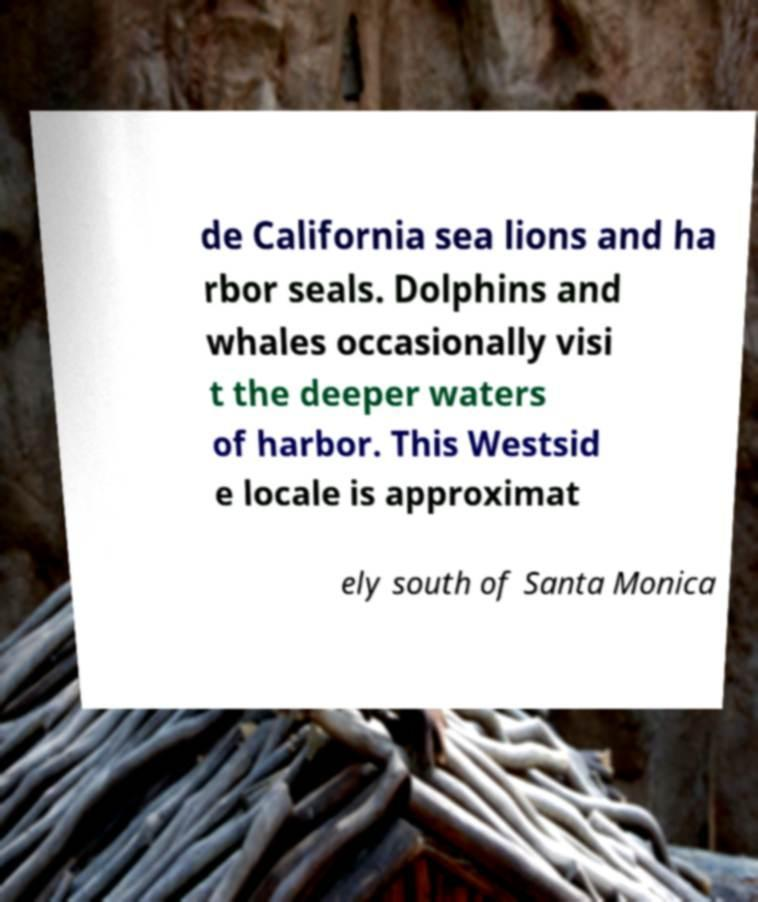Could you assist in decoding the text presented in this image and type it out clearly? de California sea lions and ha rbor seals. Dolphins and whales occasionally visi t the deeper waters of harbor. This Westsid e locale is approximat ely south of Santa Monica 